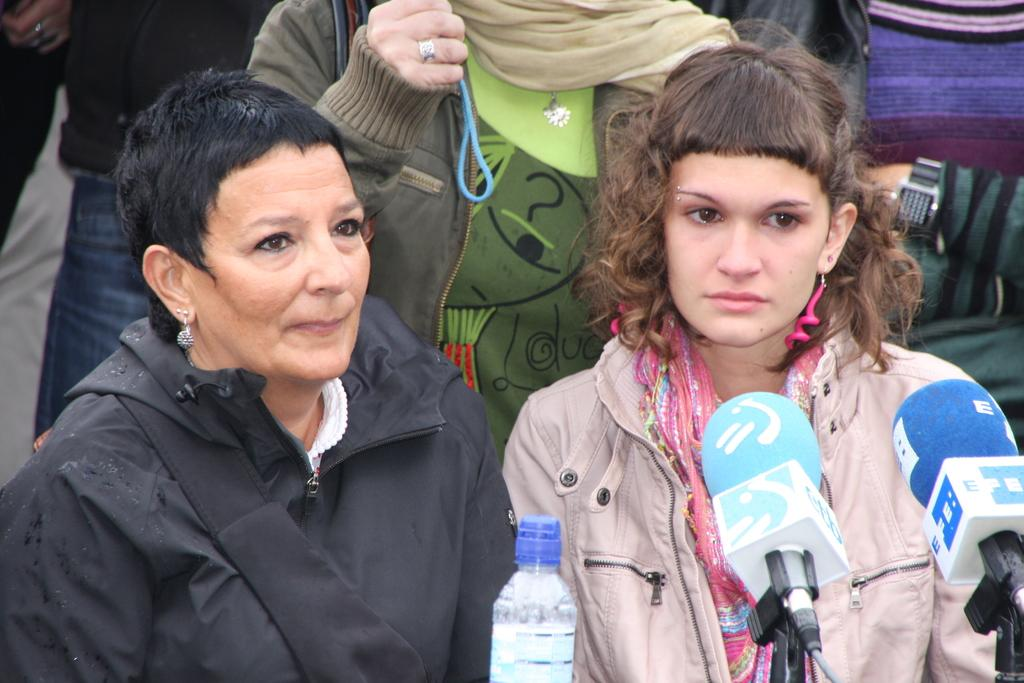Who or what can be seen in the image? There are people in the image. What object is present in the image that might be used for holding a liquid? There is a bottle in the image. What objects are present in the image that might be used for amplifying sound? There are two microphones in the image. What shape is the music taking in the image? There is no music, or any object resembling a shape for music in the image. 